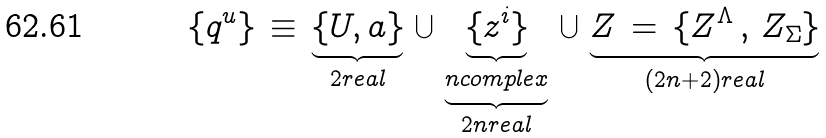<formula> <loc_0><loc_0><loc_500><loc_500>\left \{ q ^ { u } \right \} \, \equiv \, \underbrace { \{ U , a \} } _ { 2 r e a l } \, \bigcup \, \underbrace { \underbrace { \{ z ^ { i } \} } _ { n c o m p l e x } } _ { 2 n r e a l } \, \bigcup \, \underbrace { Z \, = \, \{ Z ^ { \Lambda } \, , \, Z _ { \Sigma } \} } _ { ( 2 n + 2 ) r e a l }</formula> 